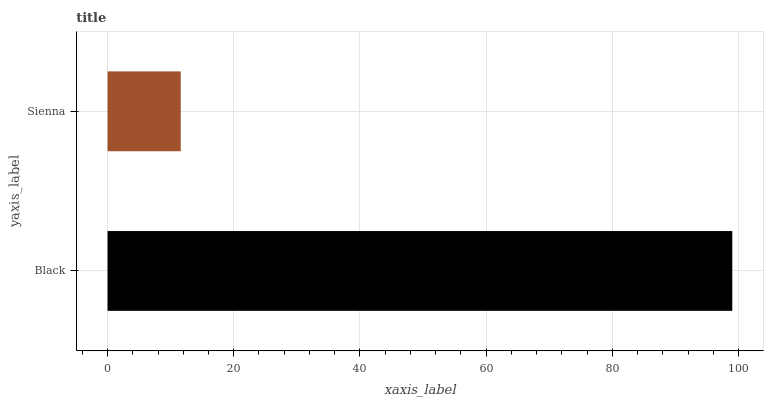Is Sienna the minimum?
Answer yes or no. Yes. Is Black the maximum?
Answer yes or no. Yes. Is Sienna the maximum?
Answer yes or no. No. Is Black greater than Sienna?
Answer yes or no. Yes. Is Sienna less than Black?
Answer yes or no. Yes. Is Sienna greater than Black?
Answer yes or no. No. Is Black less than Sienna?
Answer yes or no. No. Is Black the high median?
Answer yes or no. Yes. Is Sienna the low median?
Answer yes or no. Yes. Is Sienna the high median?
Answer yes or no. No. Is Black the low median?
Answer yes or no. No. 